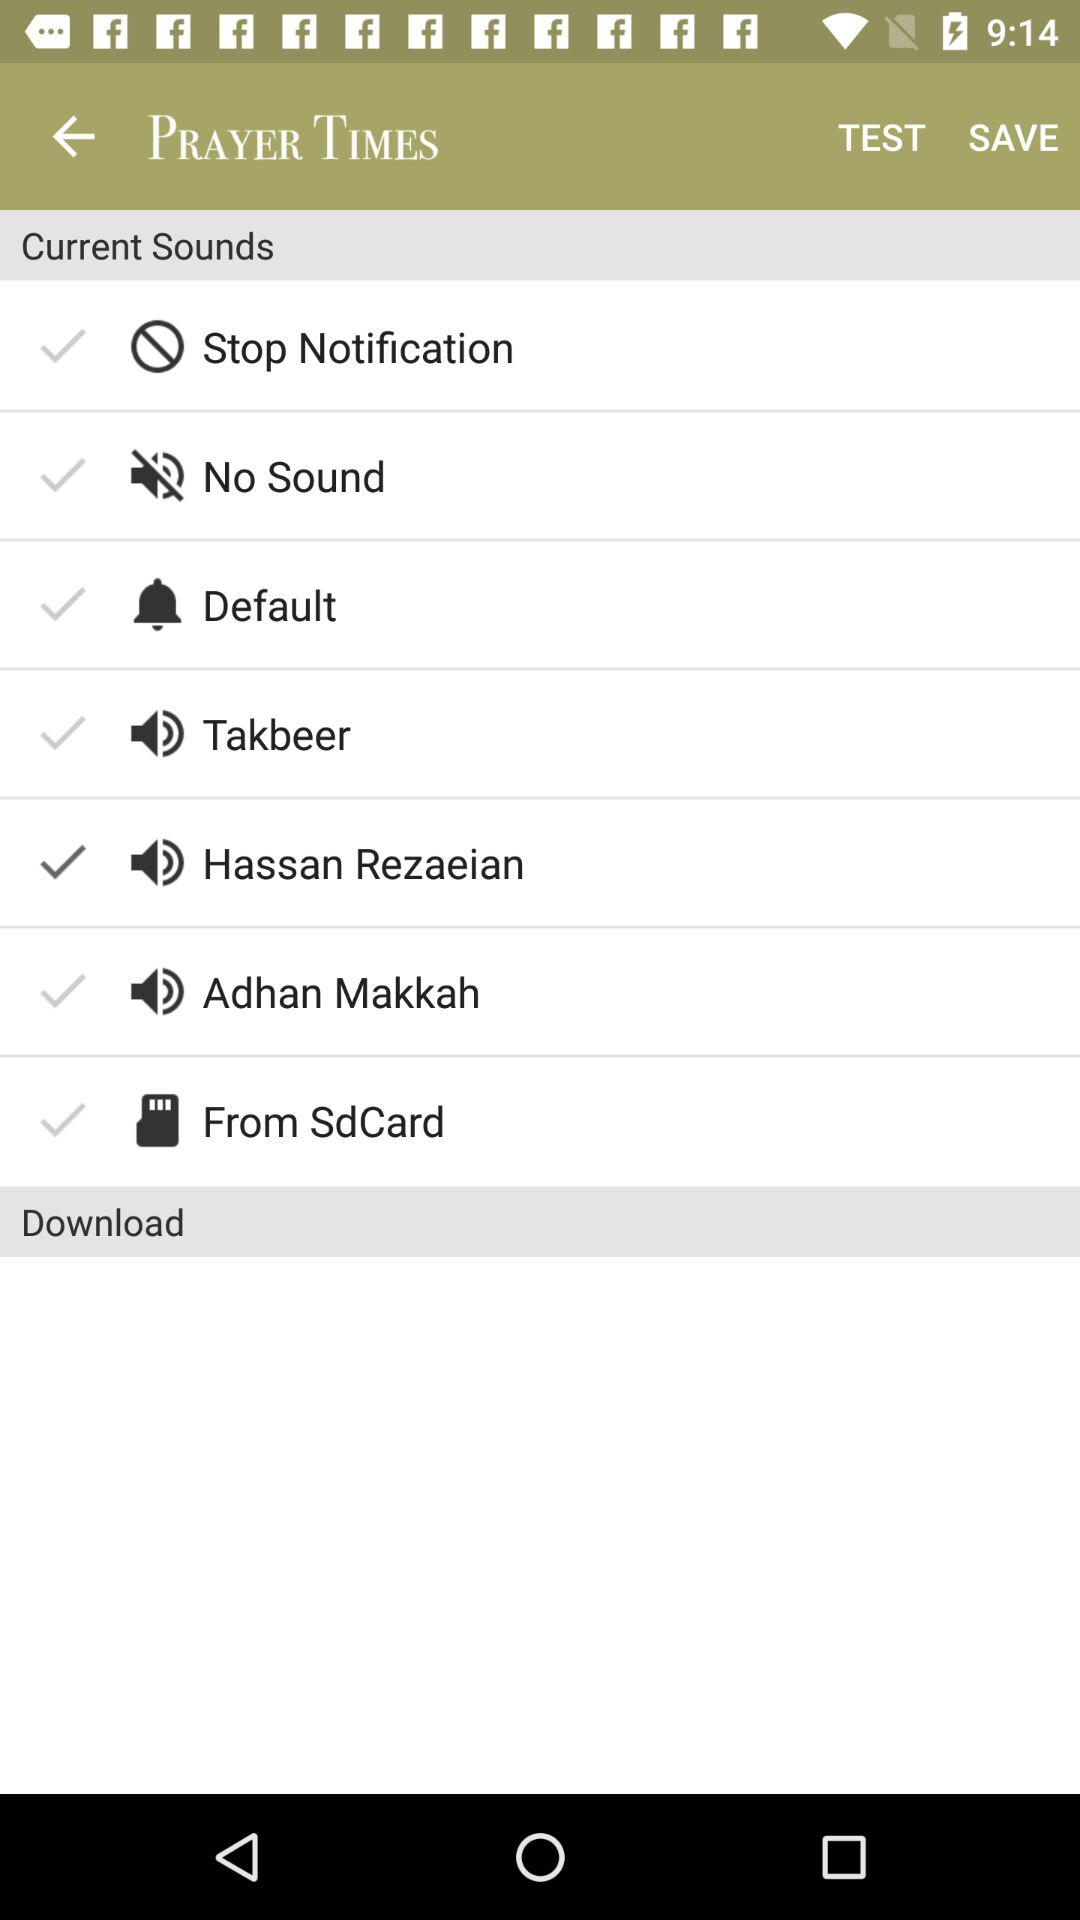Which sound is selected? The selected sound is "Hassan Rezaeian". 